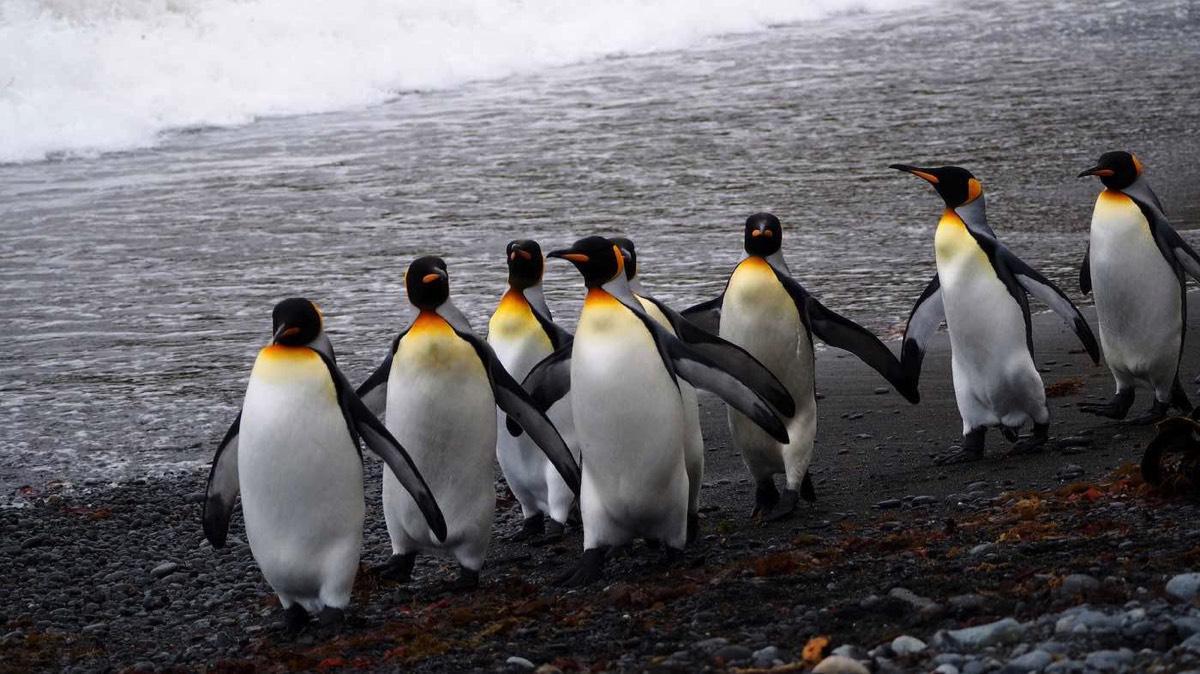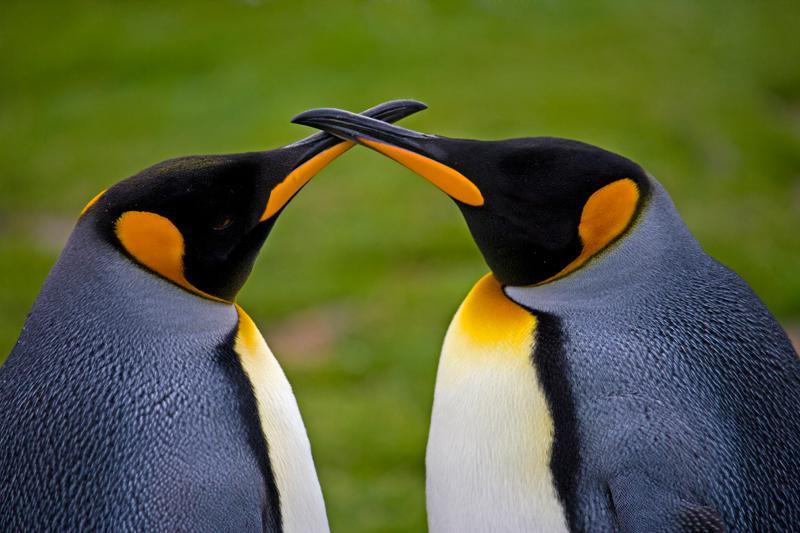The first image is the image on the left, the second image is the image on the right. Examine the images to the left and right. Is the description "There are five penguins" accurate? Answer yes or no. No. The first image is the image on the left, the second image is the image on the right. Considering the images on both sides, is "One image contains just one penguin." valid? Answer yes or no. No. 